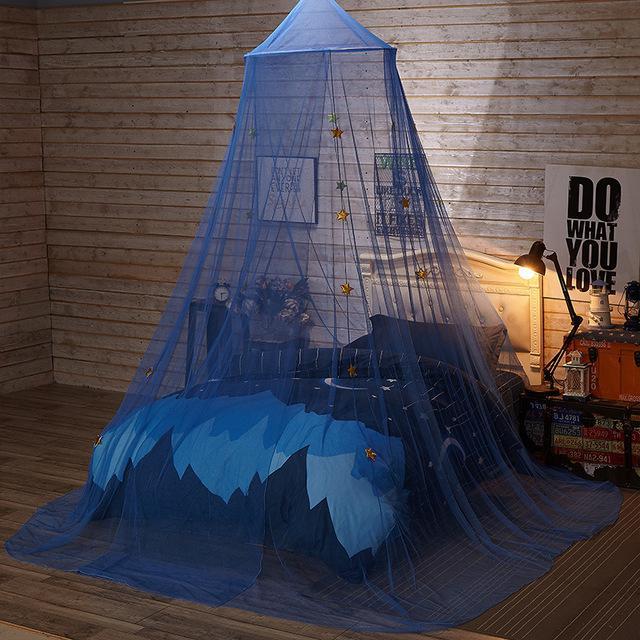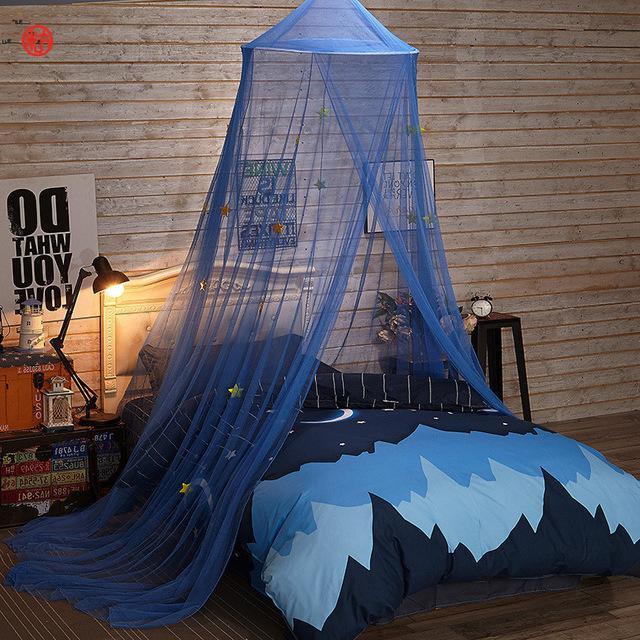The first image is the image on the left, the second image is the image on the right. Evaluate the accuracy of this statement regarding the images: "The left and right image contains the same number of blue canopies.". Is it true? Answer yes or no. Yes. The first image is the image on the left, the second image is the image on the right. For the images shown, is this caption "An image shows a suspended blue canopy that does not cover the foot of a bed with a bold print bedspread." true? Answer yes or no. Yes. 